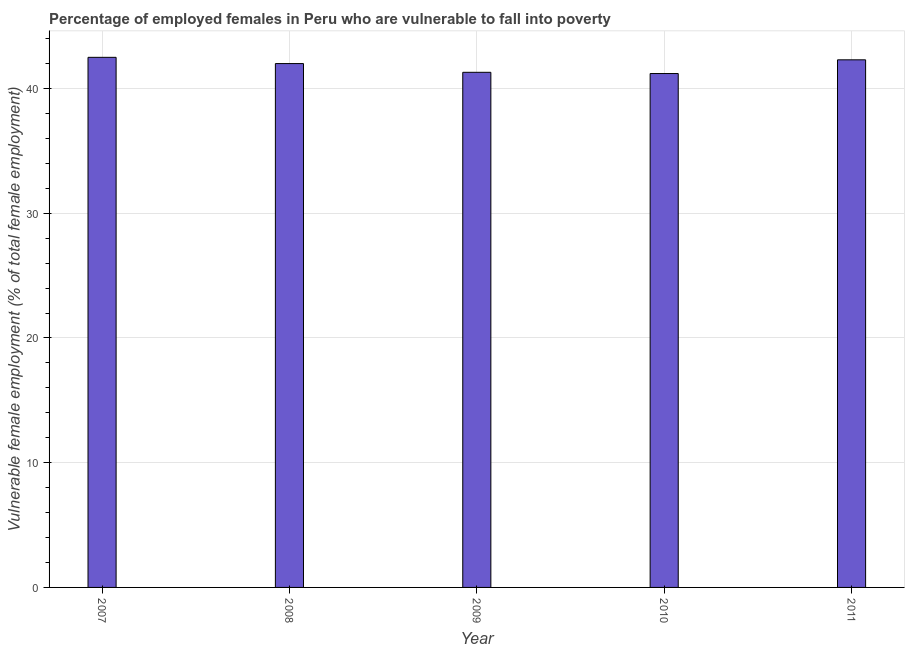Does the graph contain any zero values?
Keep it short and to the point. No. Does the graph contain grids?
Offer a terse response. Yes. What is the title of the graph?
Ensure brevity in your answer.  Percentage of employed females in Peru who are vulnerable to fall into poverty. What is the label or title of the Y-axis?
Ensure brevity in your answer.  Vulnerable female employment (% of total female employment). What is the percentage of employed females who are vulnerable to fall into poverty in 2011?
Provide a succinct answer. 42.3. Across all years, what is the maximum percentage of employed females who are vulnerable to fall into poverty?
Your response must be concise. 42.5. Across all years, what is the minimum percentage of employed females who are vulnerable to fall into poverty?
Keep it short and to the point. 41.2. In which year was the percentage of employed females who are vulnerable to fall into poverty minimum?
Make the answer very short. 2010. What is the sum of the percentage of employed females who are vulnerable to fall into poverty?
Provide a succinct answer. 209.3. What is the difference between the percentage of employed females who are vulnerable to fall into poverty in 2009 and 2011?
Your response must be concise. -1. What is the average percentage of employed females who are vulnerable to fall into poverty per year?
Make the answer very short. 41.86. What is the ratio of the percentage of employed females who are vulnerable to fall into poverty in 2009 to that in 2011?
Keep it short and to the point. 0.98. Is the percentage of employed females who are vulnerable to fall into poverty in 2007 less than that in 2009?
Ensure brevity in your answer.  No. Is the difference between the percentage of employed females who are vulnerable to fall into poverty in 2008 and 2009 greater than the difference between any two years?
Ensure brevity in your answer.  No. What is the difference between the highest and the second highest percentage of employed females who are vulnerable to fall into poverty?
Offer a terse response. 0.2. Is the sum of the percentage of employed females who are vulnerable to fall into poverty in 2008 and 2010 greater than the maximum percentage of employed females who are vulnerable to fall into poverty across all years?
Your answer should be very brief. Yes. How many bars are there?
Ensure brevity in your answer.  5. Are all the bars in the graph horizontal?
Make the answer very short. No. How many years are there in the graph?
Your answer should be very brief. 5. What is the difference between two consecutive major ticks on the Y-axis?
Offer a terse response. 10. What is the Vulnerable female employment (% of total female employment) in 2007?
Offer a terse response. 42.5. What is the Vulnerable female employment (% of total female employment) of 2009?
Keep it short and to the point. 41.3. What is the Vulnerable female employment (% of total female employment) in 2010?
Provide a succinct answer. 41.2. What is the Vulnerable female employment (% of total female employment) in 2011?
Your response must be concise. 42.3. What is the difference between the Vulnerable female employment (% of total female employment) in 2007 and 2010?
Your response must be concise. 1.3. What is the difference between the Vulnerable female employment (% of total female employment) in 2008 and 2009?
Keep it short and to the point. 0.7. What is the difference between the Vulnerable female employment (% of total female employment) in 2008 and 2011?
Your answer should be very brief. -0.3. What is the difference between the Vulnerable female employment (% of total female employment) in 2009 and 2010?
Offer a very short reply. 0.1. What is the difference between the Vulnerable female employment (% of total female employment) in 2010 and 2011?
Offer a very short reply. -1.1. What is the ratio of the Vulnerable female employment (% of total female employment) in 2007 to that in 2010?
Offer a terse response. 1.03. What is the ratio of the Vulnerable female employment (% of total female employment) in 2008 to that in 2011?
Keep it short and to the point. 0.99. What is the ratio of the Vulnerable female employment (% of total female employment) in 2009 to that in 2011?
Provide a succinct answer. 0.98. 